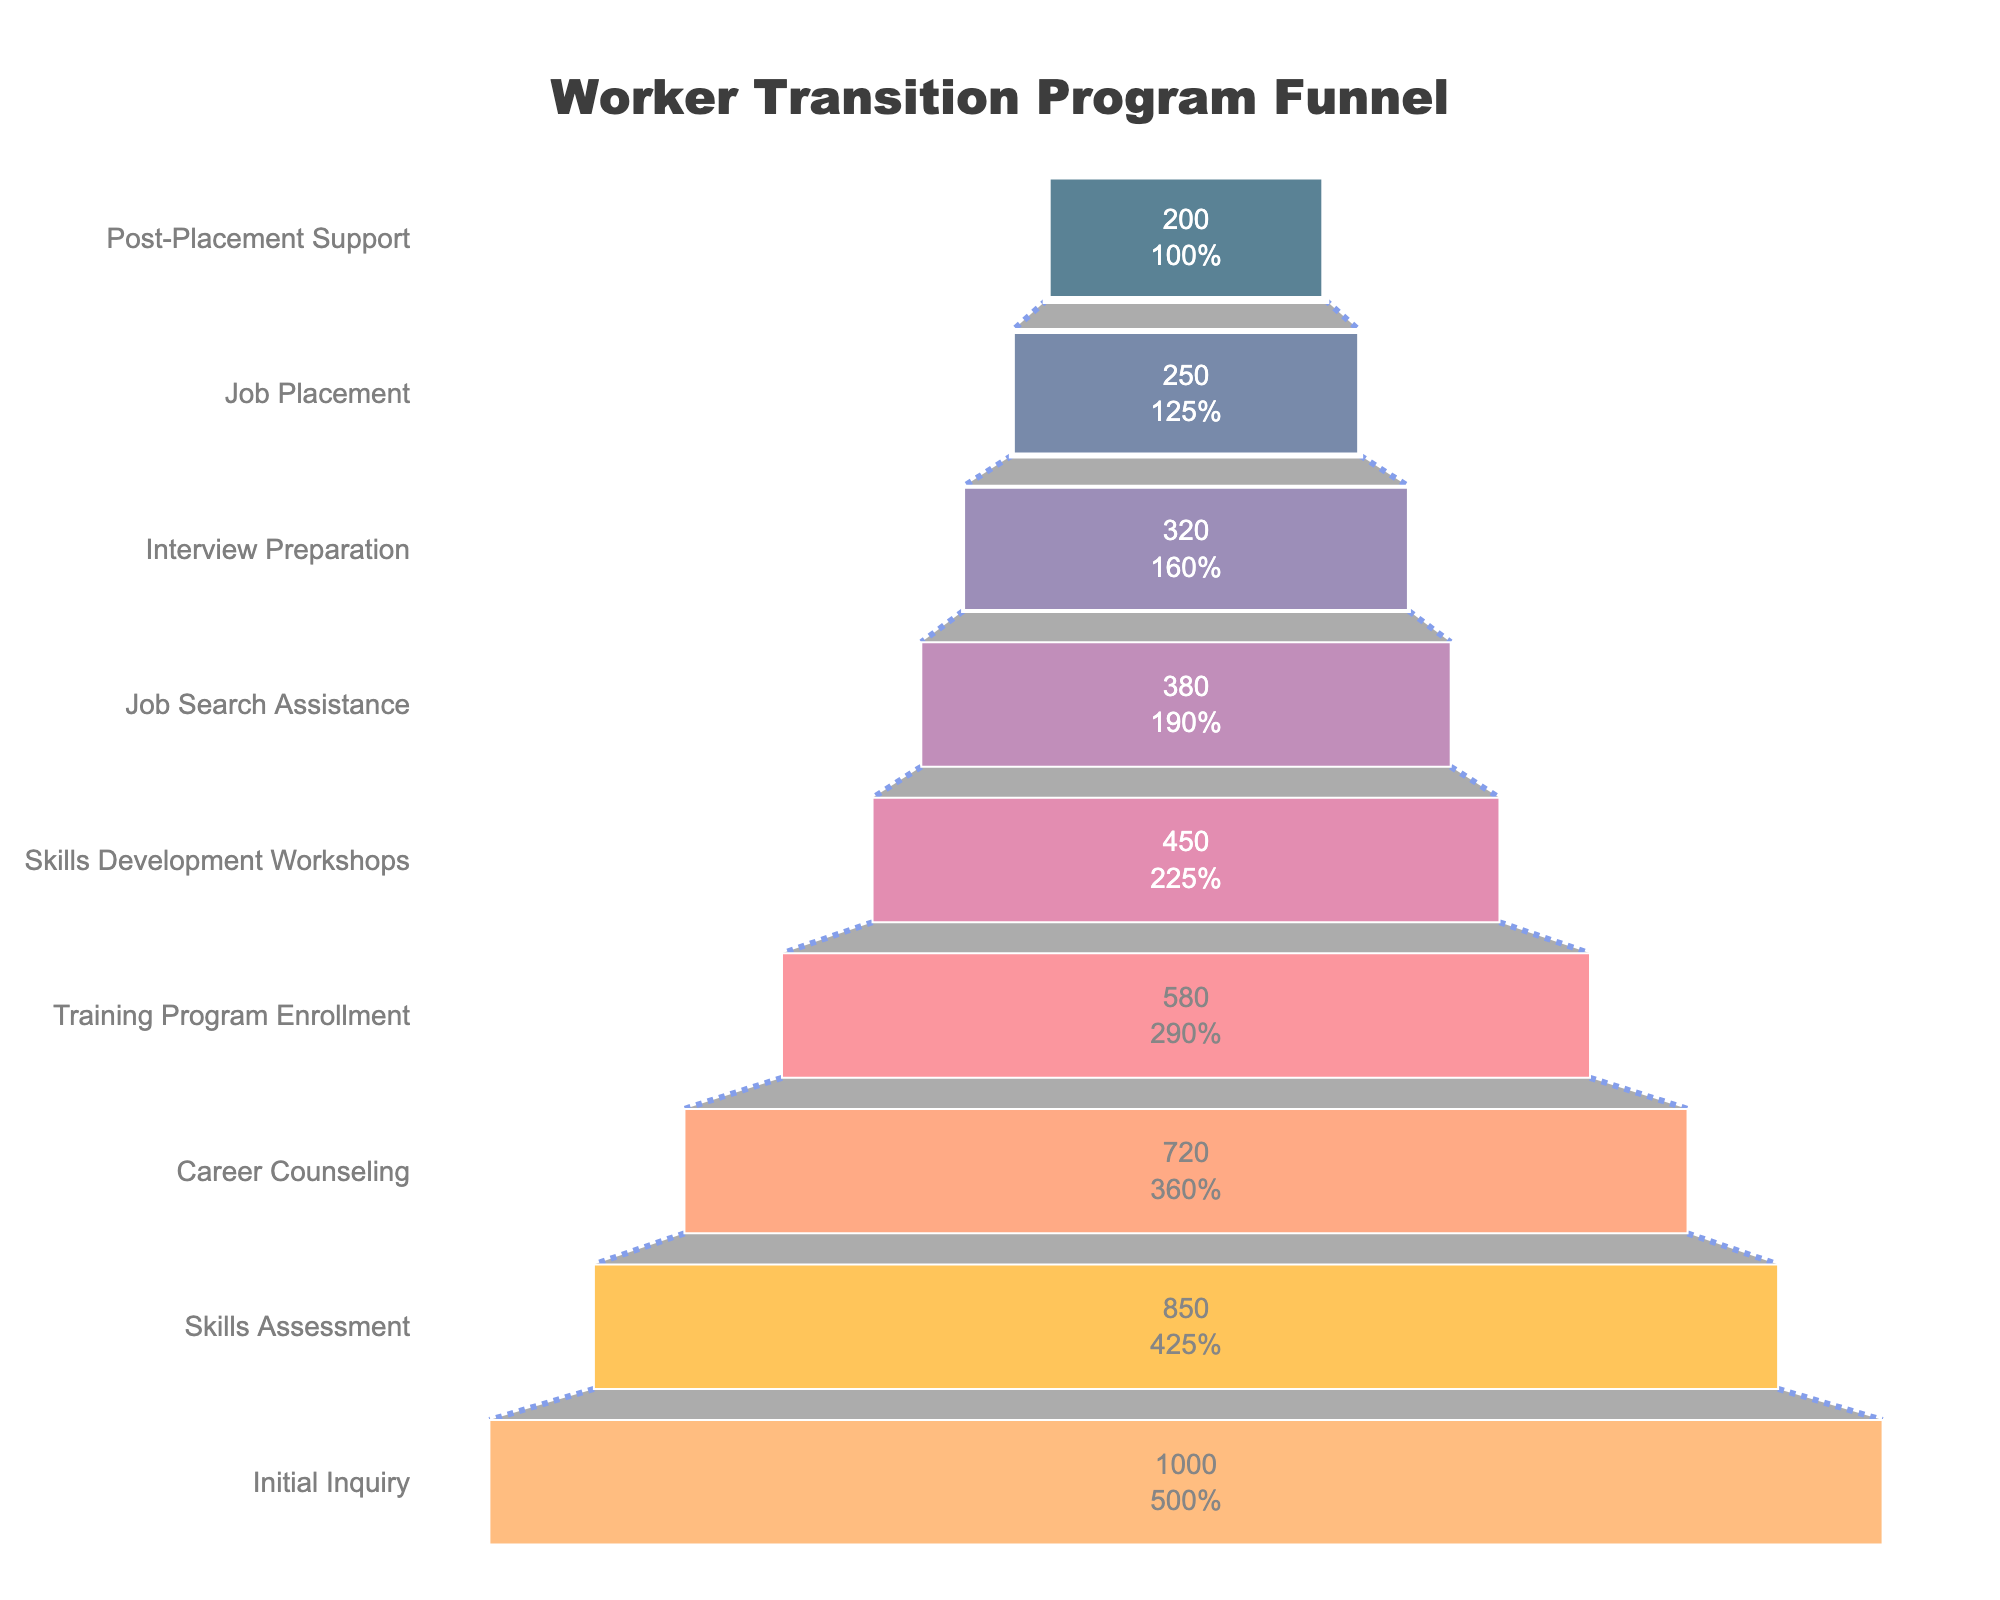What is the title of the funnel chart? The title of the chart is usually located at the top and in a larger font size than other text elements.
Answer: Worker Transition Program Funnel What is the first stage in the funnel? The first stage is typically placed at the bottom of a funnel chart. It is labeled with its name and the number of participants.
Answer: Post-Placement Support How many participants initially inquired about transition programs? The 'Initial Inquiry' stage is at the top of the funnel and displays the number of participants as a value on the bar.
Answer: 1000 How many participants completed the Skills Development Workshops? The 'Skills Development Workshops' stage shows participants on its bar within the funnel. Observe the number of participants indicated there.
Answer: 450 Which stage has the smallest percentage drop in participants compared to its previous stage? Calculate the percentage drop for each stage by comparing the number of participants in that stage with the previous one, and identify the smallest drop.
Answer: Job Search Assistance What is the total number of participants who reached the final three stages? Sum the number of participants at the final three stages: Job Search Assistance, Interview Preparation, and Job Placement.
Answer: 250 + 320 + 380 = 950 Which stage shows the largest absolute drop in the number of participants from the previous stage? Calculate the difference between the number of participants in each consecutive stage and identify the largest drop.
Answer: Training Program Enrollment to Skills Development Workshops How many stages have more than 500 participants? Count the stages with participant numbers greater than 500, visible in their respective bars.
Answer: 3 What proportion of participants completed the Career Counseling stage compared to the Skills Assessment stage? Divide the number of participants in the Career Counseling stage by the number of participants in the Skills Assessment stage and convert it to a percentage.
Answer: 720 / 850 ≈ 0.847 or 84.7% What is the percentage retention from Initial Inquiry to Job Placement? Divide the number of participants in Job Placement by those in Initial Inquiry, and multiply by 100 to get the percentage.
Answer: (250 / 1000) * 100 = 25% 